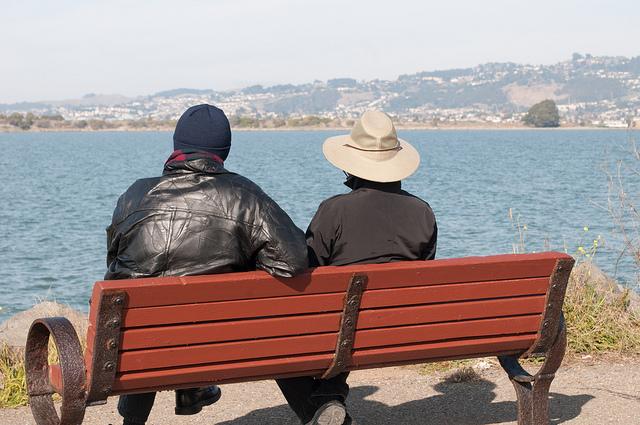Is it sunny?
Concise answer only. Yes. How many people are seated?
Short answer required. 2. What color hat is the person on the left wearing?
Concise answer only. Blue. 